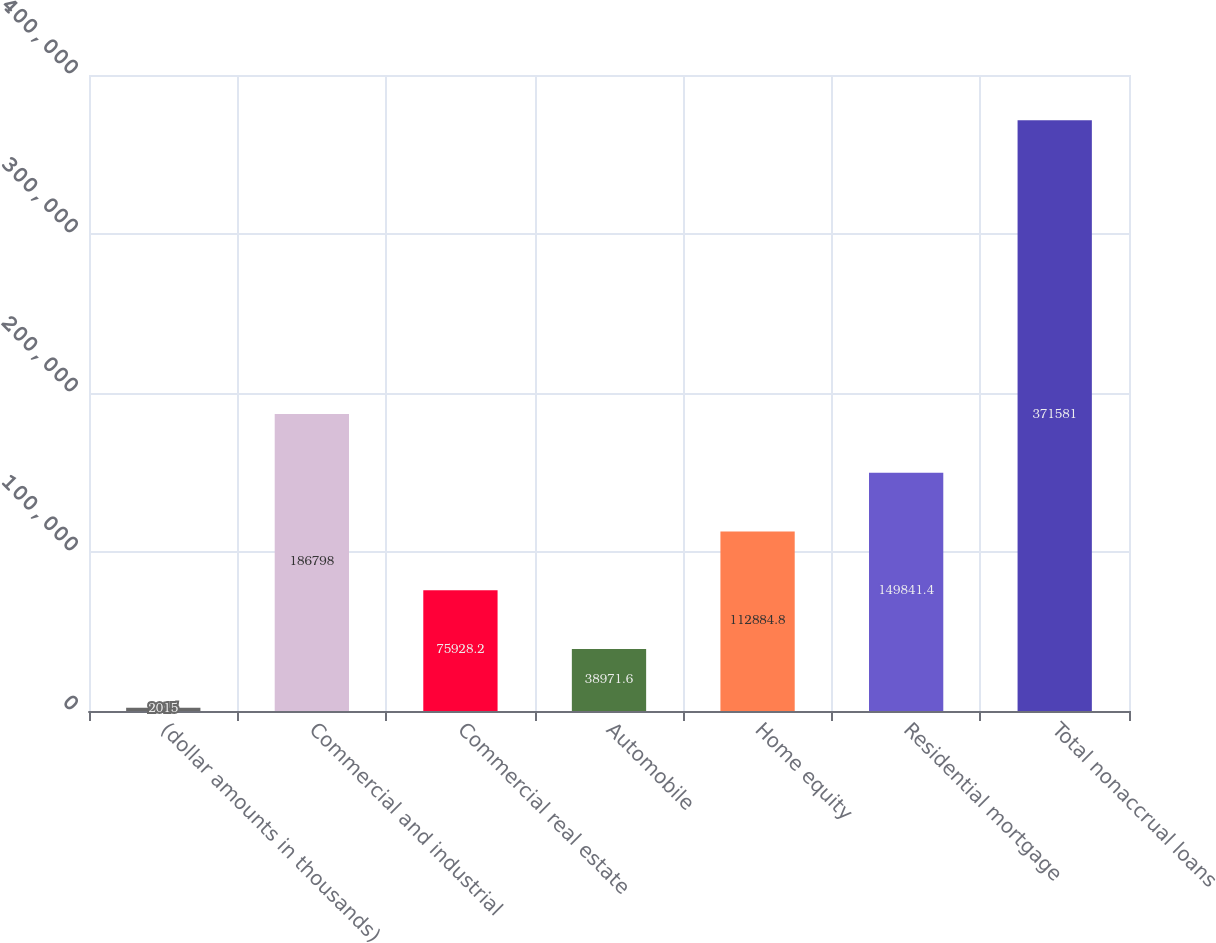Convert chart to OTSL. <chart><loc_0><loc_0><loc_500><loc_500><bar_chart><fcel>(dollar amounts in thousands)<fcel>Commercial and industrial<fcel>Commercial real estate<fcel>Automobile<fcel>Home equity<fcel>Residential mortgage<fcel>Total nonaccrual loans<nl><fcel>2015<fcel>186798<fcel>75928.2<fcel>38971.6<fcel>112885<fcel>149841<fcel>371581<nl></chart> 